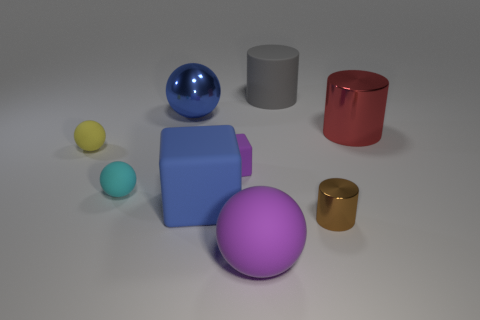Is there a blue metal sphere on the left side of the rubber ball in front of the tiny matte ball that is in front of the yellow matte sphere?
Ensure brevity in your answer.  Yes. What number of cyan rubber balls have the same size as the gray rubber object?
Provide a short and direct response. 0. There is a object that is behind the blue metallic ball; is it the same size as the sphere that is behind the yellow object?
Ensure brevity in your answer.  Yes. What shape is the rubber thing that is both in front of the yellow object and to the left of the large blue metal thing?
Your answer should be very brief. Sphere. Are there any small blocks that have the same color as the large block?
Give a very brief answer. No. Is there a red shiny cylinder?
Provide a succinct answer. Yes. What is the color of the big sphere that is in front of the tiny brown shiny object?
Offer a terse response. Purple. Does the cyan rubber object have the same size as the blue object that is in front of the red thing?
Your answer should be compact. No. How big is the object that is in front of the big blue rubber block and on the left side of the gray cylinder?
Your answer should be compact. Large. Is there a tiny thing that has the same material as the big blue block?
Your answer should be compact. Yes. 